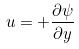<formula> <loc_0><loc_0><loc_500><loc_500>u = + \frac { \partial \psi } { \partial y }</formula> 